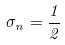<formula> <loc_0><loc_0><loc_500><loc_500>\sigma _ { n } = \frac { 1 } { 2 }</formula> 